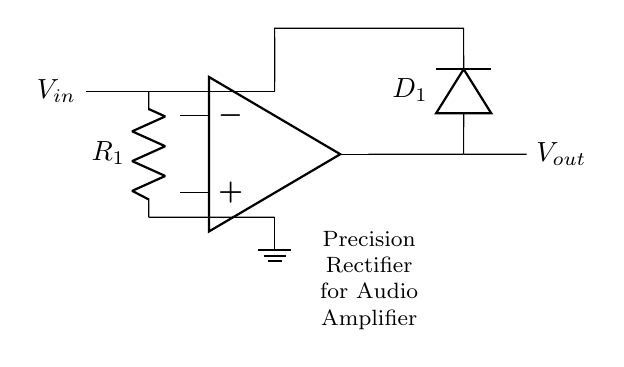What type of circuit is shown? The circuit is a precision rectifier, as indicated by the labels and the configuration with an operational amplifier and a diode for smoothing the rectification.
Answer: Precision Rectifier What is the role of the resistor R1 in the circuit? The resistor R1 is used to limit the input current to the operational amplifier, ensuring that the input is within a safe range for the gain and preventing damage to the op-amp.
Answer: Current Limiting What component is used for rectification? The diode D1 is the component responsible for rectification, allowing current to flow in one direction while blocking it in the reverse direction, which is essential for converting the AC input to a DC output.
Answer: Diode Where is the output voltage measured? The output voltage Vout is measured across the diode D1 and the op-amp output, which reflects the rectified signal processed by the op-amp.
Answer: Across D1 What is the function of the operational amplifier in this circuit? The operational amplifier amplifies the input signal before it is rectified by the diode, enabling precise rectification with minimal loss and high fidelity, which is especially important for audio applications.
Answer: Signal Amplification What happens to the output voltage if the input voltage is negative? If the input voltage is negative, the diode becomes reverse-biased, blocking current flow and resulting in an output voltage of zero, as the rectifier does not allow negative voltages to pass through.
Answer: Zero Volts What type of signals is this circuit designed to work with? This precision rectifier circuit is specifically designed to work with audio signals, which are low-level AC signals requiring accurate rectification for high-fidelity reproduction.
Answer: Audio Signals 